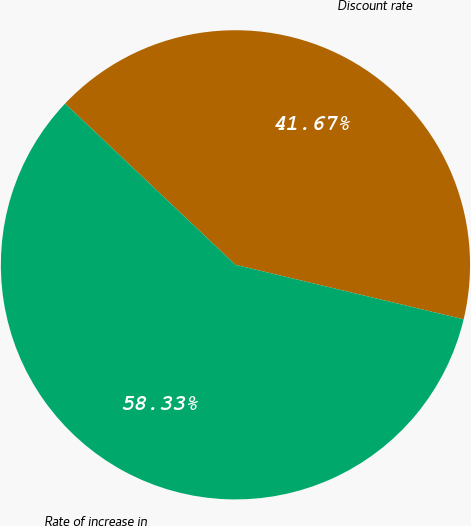Convert chart to OTSL. <chart><loc_0><loc_0><loc_500><loc_500><pie_chart><fcel>Discount rate<fcel>Rate of increase in<nl><fcel>41.67%<fcel>58.33%<nl></chart> 